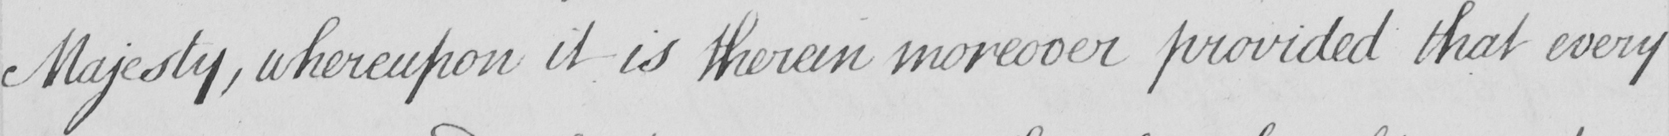What text is written in this handwritten line? Majesty , whereupon it is therein moreover provided that every 